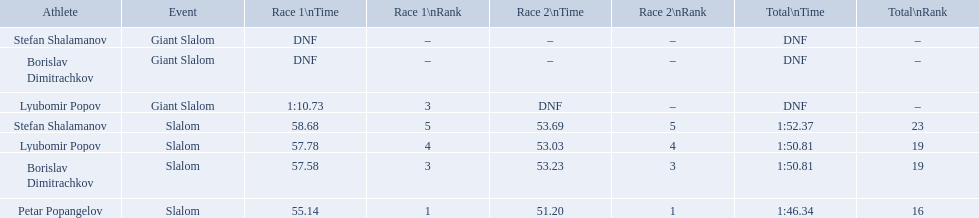What were the event names during bulgaria at the 1988 winter olympics? Stefan Shalamanov, Borislav Dimitrachkov, Lyubomir Popov. And which players participated at giant slalom? Giant Slalom, Giant Slalom, Giant Slalom, Slalom, Slalom, Slalom, Slalom. What were their race 1 times? DNF, DNF, 1:10.73. What was lyubomir popov's personal time? 1:10.73. 